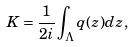<formula> <loc_0><loc_0><loc_500><loc_500>K = \frac { 1 } { 2 i } \int _ { \Lambda } q ( z ) d z ,</formula> 